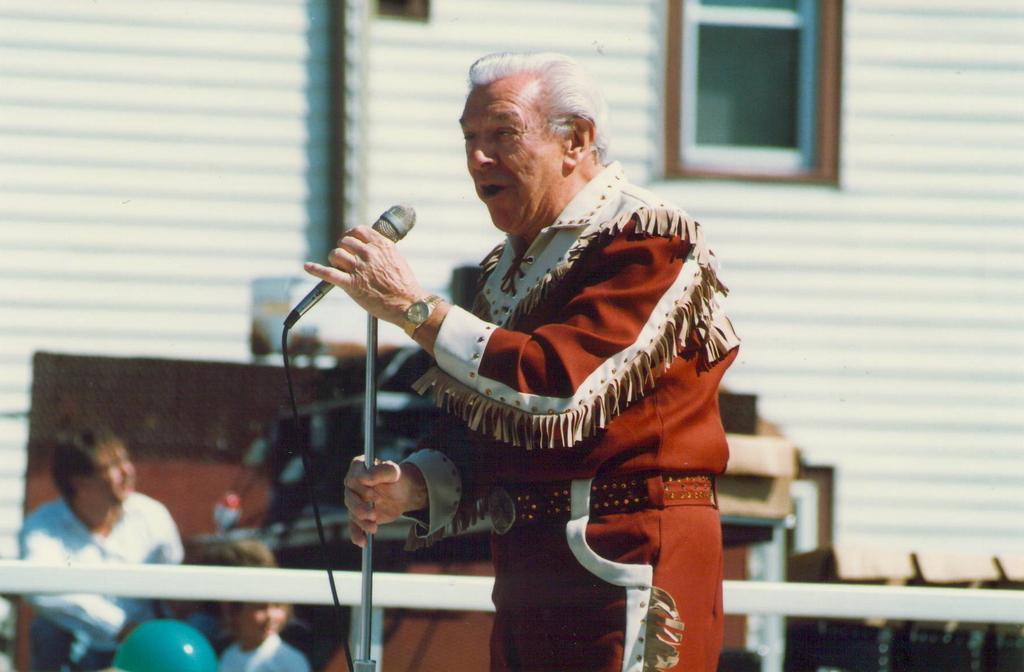In one or two sentences, can you explain what this image depicts? In this picture there is a man standing and holding a mic. To the right , a person and a girl is seen. There is a green balloon and a wooden desk in the background. 